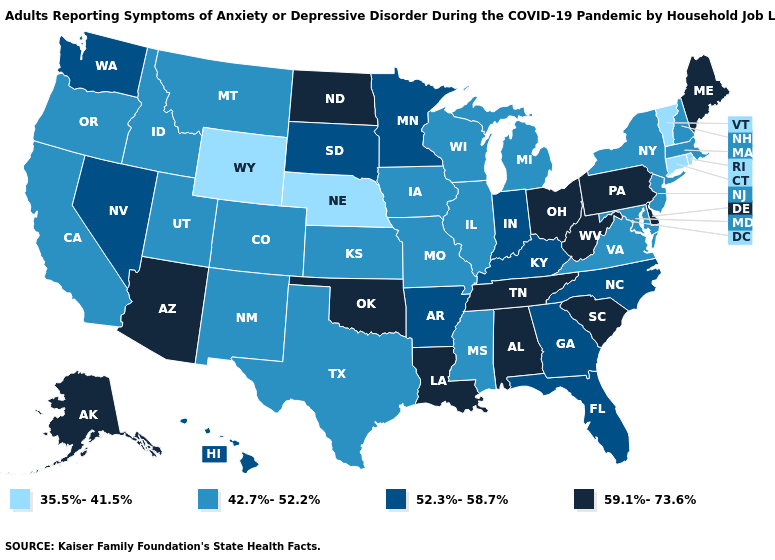What is the value of Washington?
Keep it brief. 52.3%-58.7%. What is the value of Oregon?
Short answer required. 42.7%-52.2%. Among the states that border Nevada , does Arizona have the lowest value?
Write a very short answer. No. Name the states that have a value in the range 59.1%-73.6%?
Be succinct. Alabama, Alaska, Arizona, Delaware, Louisiana, Maine, North Dakota, Ohio, Oklahoma, Pennsylvania, South Carolina, Tennessee, West Virginia. Name the states that have a value in the range 35.5%-41.5%?
Write a very short answer. Connecticut, Nebraska, Rhode Island, Vermont, Wyoming. What is the value of Nebraska?
Answer briefly. 35.5%-41.5%. Name the states that have a value in the range 52.3%-58.7%?
Quick response, please. Arkansas, Florida, Georgia, Hawaii, Indiana, Kentucky, Minnesota, Nevada, North Carolina, South Dakota, Washington. Does Connecticut have the highest value in the USA?
Give a very brief answer. No. What is the lowest value in states that border Virginia?
Keep it brief. 42.7%-52.2%. What is the value of Indiana?
Give a very brief answer. 52.3%-58.7%. What is the value of Georgia?
Be succinct. 52.3%-58.7%. Does New York have a higher value than Tennessee?
Write a very short answer. No. Does Alaska have the highest value in the USA?
Answer briefly. Yes. What is the value of Delaware?
Give a very brief answer. 59.1%-73.6%. 